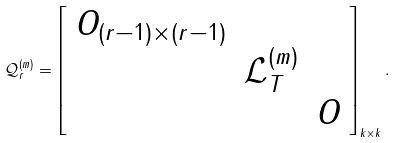Convert formula to latex. <formula><loc_0><loc_0><loc_500><loc_500>\mathcal { Q } ^ { ( m ) } _ { r } = \left [ \begin{array} { r r r } O _ { ( r - 1 ) \times ( r - 1 ) } & & \\ & \mathcal { L } _ { T } ^ { ( m ) } & \\ & & O \end{array} \right ] _ { k \times k } .</formula> 